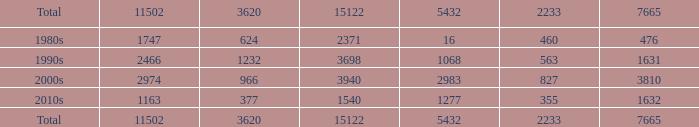What is the average 5432 value with a 11502 larger than 1163, a 15122 less than 15122, and a 3620 less than 624? None. 